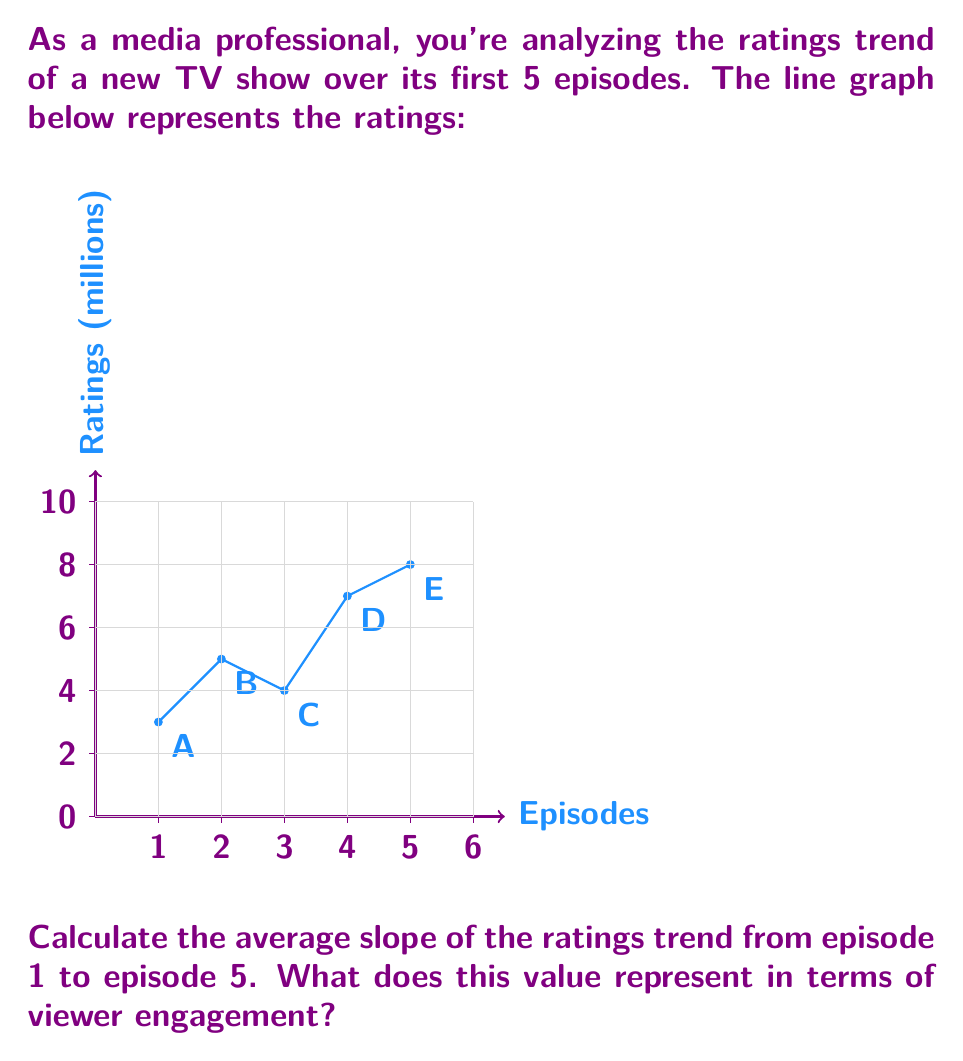Provide a solution to this math problem. To solve this problem, we'll follow these steps:

1) The slope between two points is calculated using the formula:
   $$ \text{slope} = \frac{\text{change in y}}{\text{change in x}} = \frac{y_2 - y_1}{x_2 - x_1} $$

2) We need to find the slope between the first (A) and last (E) points:
   Point A: (1, 3)
   Point E: (5, 8)

3) Applying the formula:
   $$ \text{slope} = \frac{8 - 3}{5 - 1} = \frac{5}{4} = 1.25 $$

4) This slope represents the average rate of change in ratings over the 5 episodes.

5) Interpreting the result:
   - A positive slope indicates an upward trend in ratings.
   - The value 1.25 means that, on average, the show gained 1.25 million viewers per episode.

6) In terms of viewer engagement, this positive slope suggests increasing interest and growing audience retention over time, which is a good sign for a new TV show.
Answer: 1.25 million viewers/episode; increasing viewer engagement 